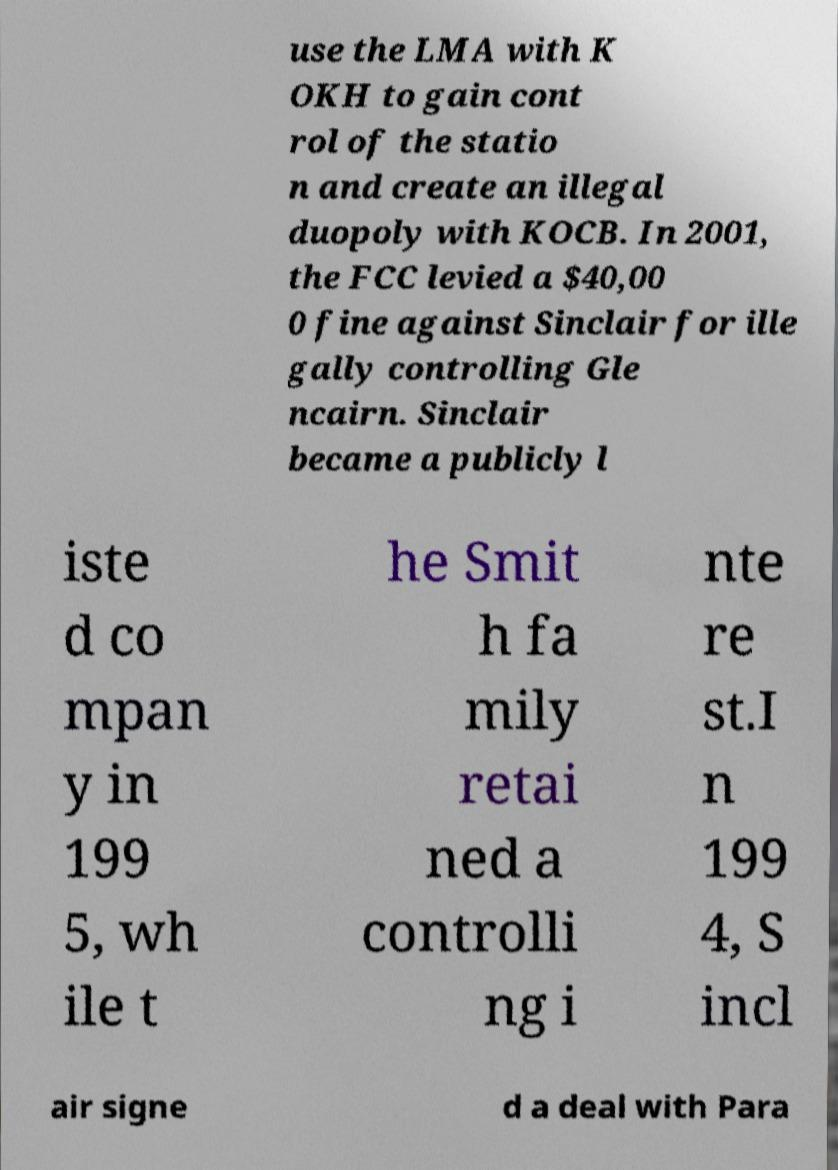For documentation purposes, I need the text within this image transcribed. Could you provide that? use the LMA with K OKH to gain cont rol of the statio n and create an illegal duopoly with KOCB. In 2001, the FCC levied a $40,00 0 fine against Sinclair for ille gally controlling Gle ncairn. Sinclair became a publicly l iste d co mpan y in 199 5, wh ile t he Smit h fa mily retai ned a controlli ng i nte re st.I n 199 4, S incl air signe d a deal with Para 